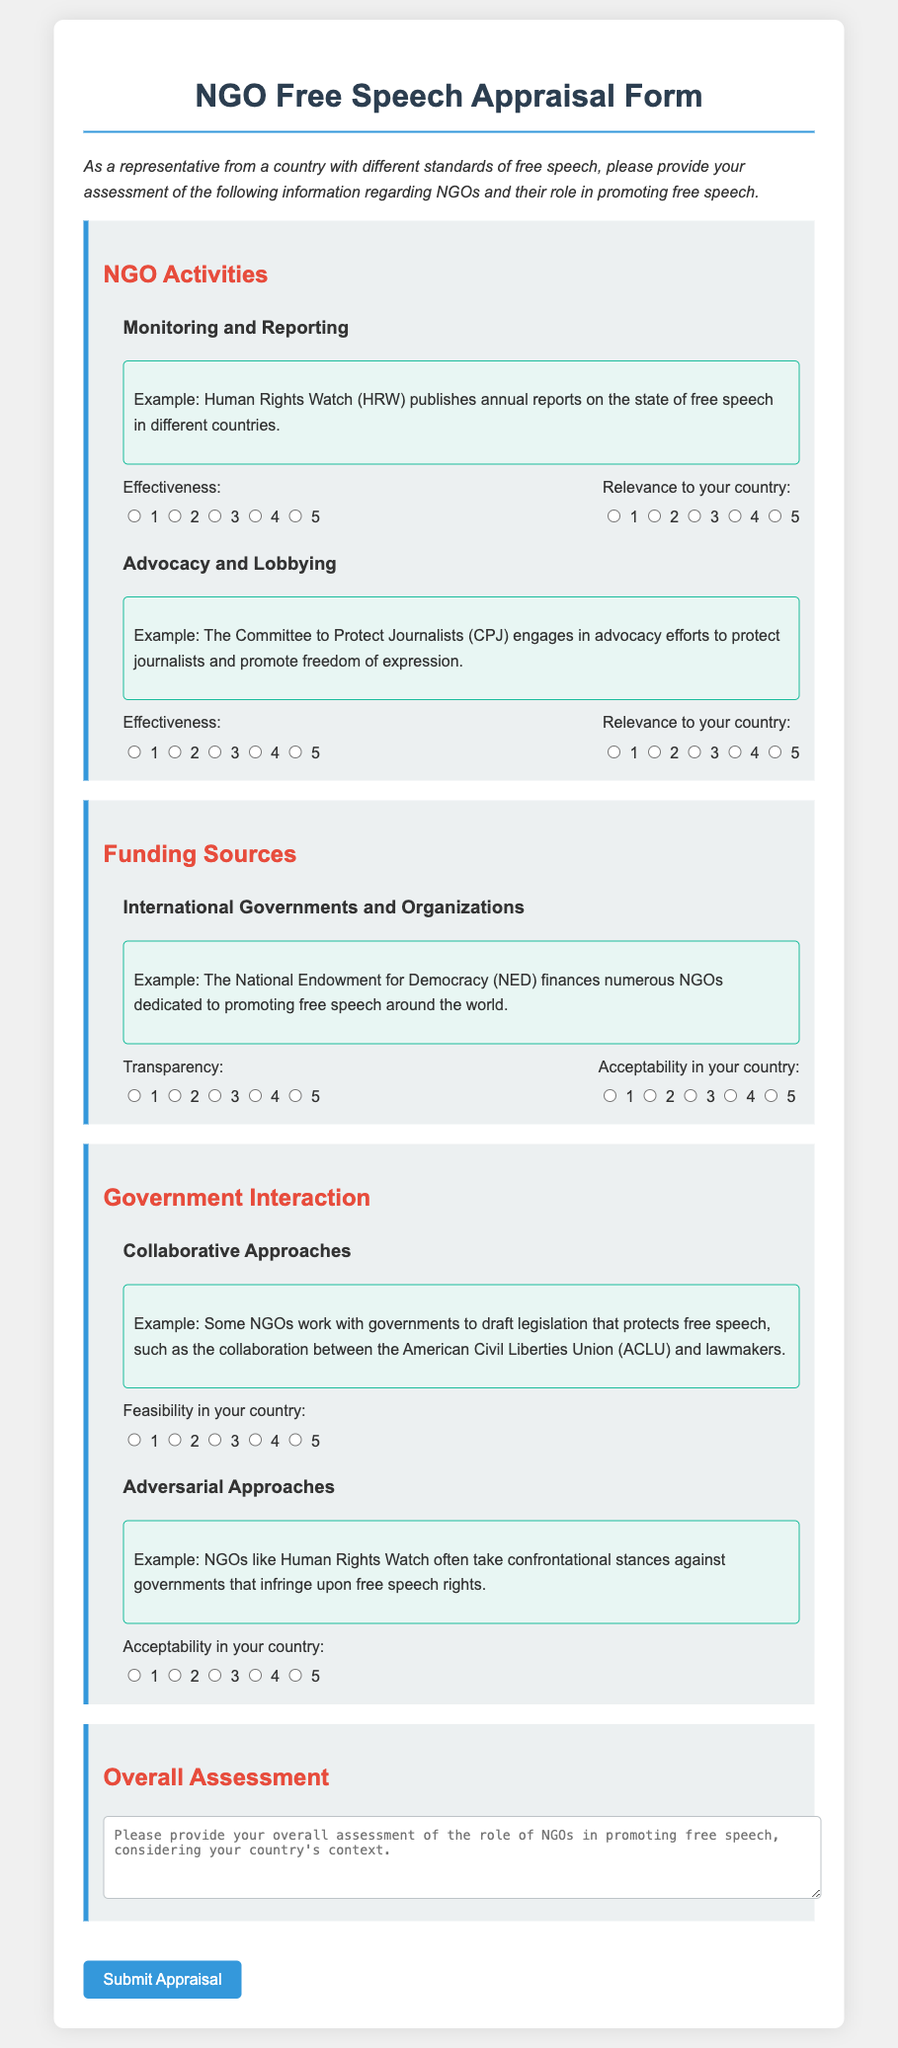What is the title of the form? The title of the form is stated at the top of the document, which provides the purpose of the content.
Answer: NGO Free Speech Appraisal Form What is the effectiveness rating scale used in the document? The effectiveness rating scale is defined as a set of numbers used to measure effectiveness, typically from 1 to 5.
Answer: 1 to 5 Who published annual reports on free speech? An example in the document mentions a specific organization that publishes these reports, indicating its role in monitoring.
Answer: Human Rights Watch What is the primary example of advocacy mentioned? The form provides an example of an organization engaged in advocacy to illustrate its role, particularly in protecting rights.
Answer: The Committee to Protect Journalists What does the NGO example for funding indicate about transparency? The funding section discusses how international organizations financially support NGOs, emphasizing the significance of a specific aspect.
Answer: Transparency What collaborative action is suggested for NGOs? The document mentions a specific type of action that NGOs can take to engage with governments regarding free speech.
Answer: Draft legislation What is the purpose of the overall assessment section? This section is designed for respondents to provide a summary perspective based on their country’s context regarding the theme addressed in the document.
Answer: Overall assessment What is the main focus of the appraisal form? The main focus is on understanding how NGOs facilitate a specific democratic principle, which is detailed in the title and the introduction.
Answer: Promoting free speech 